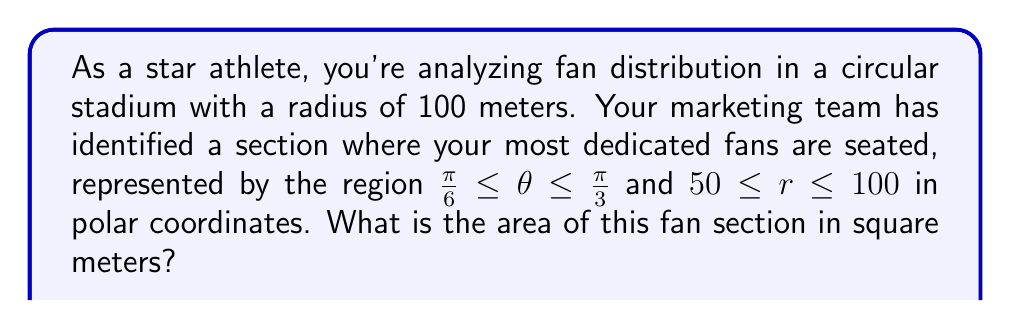Could you help me with this problem? To solve this problem, we need to use the formula for the area of a sector in polar coordinates:

$$ A = \frac{1}{2} \int_{\theta_1}^{\theta_2} \int_{r_1}^{r_2} r \, dr \, d\theta $$

Where:
- $\theta_1 = \frac{\pi}{6}$ and $\theta_2 = \frac{\pi}{3}$ are the angular bounds
- $r_1 = 50$ and $r_2 = 100$ are the radial bounds

Let's solve this step by step:

1) First, let's integrate with respect to r:

   $$ A = \frac{1}{2} \int_{\frac{\pi}{6}}^{\frac{\pi}{3}} \left[ \frac{r^2}{2} \right]_{50}^{100} d\theta $$

2) Evaluate the inner integral:

   $$ A = \frac{1}{2} \int_{\frac{\pi}{6}}^{\frac{\pi}{3}} \left( \frac{100^2}{2} - \frac{50^2}{2} \right) d\theta $$

3) Simplify:

   $$ A = \frac{1}{2} \int_{\frac{\pi}{6}}^{\frac{\pi}{3}} (5000 - 1250) d\theta = \frac{1}{2} \int_{\frac{\pi}{6}}^{\frac{\pi}{3}} 3750 \, d\theta $$

4) Now integrate with respect to θ:

   $$ A = \frac{1}{2} \cdot 3750 \left[ \theta \right]_{\frac{\pi}{6}}^{\frac{\pi}{3}} = 1875 \left( \frac{\pi}{3} - \frac{\pi}{6} \right) $$

5) Simplify:

   $$ A = 1875 \cdot \frac{\pi}{6} = 312.5\pi $$

Therefore, the area of the fan section is $312.5\pi$ square meters.
Answer: $312.5\pi$ square meters 